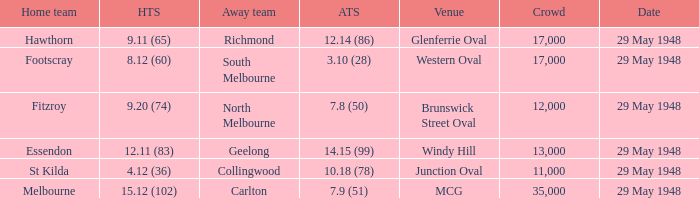Parse the full table. {'header': ['Home team', 'HTS', 'Away team', 'ATS', 'Venue', 'Crowd', 'Date'], 'rows': [['Hawthorn', '9.11 (65)', 'Richmond', '12.14 (86)', 'Glenferrie Oval', '17,000', '29 May 1948'], ['Footscray', '8.12 (60)', 'South Melbourne', '3.10 (28)', 'Western Oval', '17,000', '29 May 1948'], ['Fitzroy', '9.20 (74)', 'North Melbourne', '7.8 (50)', 'Brunswick Street Oval', '12,000', '29 May 1948'], ['Essendon', '12.11 (83)', 'Geelong', '14.15 (99)', 'Windy Hill', '13,000', '29 May 1948'], ['St Kilda', '4.12 (36)', 'Collingwood', '10.18 (78)', 'Junction Oval', '11,000', '29 May 1948'], ['Melbourne', '15.12 (102)', 'Carlton', '7.9 (51)', 'MCG', '35,000', '29 May 1948']]} During melbourne's home game, who was the away team? Carlton. 